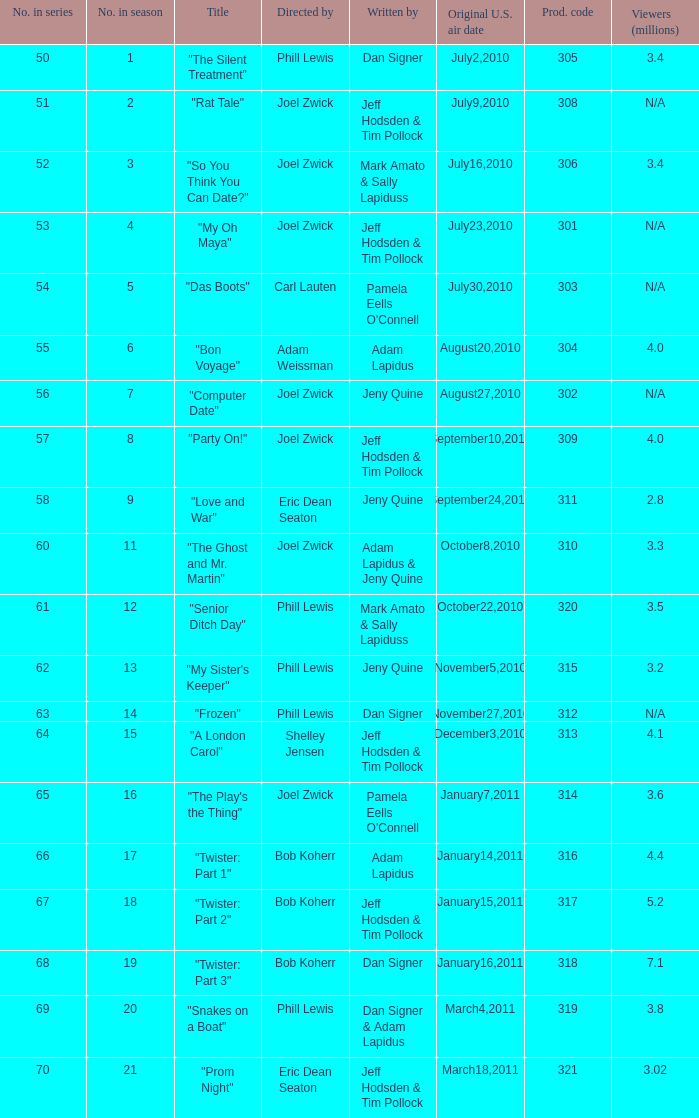Can you give me this table as a dict? {'header': ['No. in series', 'No. in season', 'Title', 'Directed by', 'Written by', 'Original U.S. air date', 'Prod. code', 'Viewers (millions)'], 'rows': [['50', '1', '"The Silent Treatment"', 'Phill Lewis', 'Dan Signer', 'July2,2010', '305', '3.4'], ['51', '2', '"Rat Tale"', 'Joel Zwick', 'Jeff Hodsden & Tim Pollock', 'July9,2010', '308', 'N/A'], ['52', '3', '"So You Think You Can Date?"', 'Joel Zwick', 'Mark Amato & Sally Lapiduss', 'July16,2010', '306', '3.4'], ['53', '4', '"My Oh Maya"', 'Joel Zwick', 'Jeff Hodsden & Tim Pollock', 'July23,2010', '301', 'N/A'], ['54', '5', '"Das Boots"', 'Carl Lauten', "Pamela Eells O'Connell", 'July30,2010', '303', 'N/A'], ['55', '6', '"Bon Voyage"', 'Adam Weissman', 'Adam Lapidus', 'August20,2010', '304', '4.0'], ['56', '7', '"Computer Date"', 'Joel Zwick', 'Jeny Quine', 'August27,2010', '302', 'N/A'], ['57', '8', '"Party On!"', 'Joel Zwick', 'Jeff Hodsden & Tim Pollock', 'September10,2010', '309', '4.0'], ['58', '9', '"Love and War"', 'Eric Dean Seaton', 'Jeny Quine', 'September24,2010', '311', '2.8'], ['60', '11', '"The Ghost and Mr. Martin"', 'Joel Zwick', 'Adam Lapidus & Jeny Quine', 'October8,2010', '310', '3.3'], ['61', '12', '"Senior Ditch Day"', 'Phill Lewis', 'Mark Amato & Sally Lapiduss', 'October22,2010', '320', '3.5'], ['62', '13', '"My Sister\'s Keeper"', 'Phill Lewis', 'Jeny Quine', 'November5,2010', '315', '3.2'], ['63', '14', '"Frozen"', 'Phill Lewis', 'Dan Signer', 'November27,2010', '312', 'N/A'], ['64', '15', '"A London Carol"', 'Shelley Jensen', 'Jeff Hodsden & Tim Pollock', 'December3,2010', '313', '4.1'], ['65', '16', '"The Play\'s the Thing"', 'Joel Zwick', "Pamela Eells O'Connell", 'January7,2011', '314', '3.6'], ['66', '17', '"Twister: Part 1"', 'Bob Koherr', 'Adam Lapidus', 'January14,2011', '316', '4.4'], ['67', '18', '"Twister: Part 2"', 'Bob Koherr', 'Jeff Hodsden & Tim Pollock', 'January15,2011', '317', '5.2'], ['68', '19', '"Twister: Part 3"', 'Bob Koherr', 'Dan Signer', 'January16,2011', '318', '7.1'], ['69', '20', '"Snakes on a Boat"', 'Phill Lewis', 'Dan Signer & Adam Lapidus', 'March4,2011', '319', '3.8'], ['70', '21', '"Prom Night"', 'Eric Dean Seaton', 'Jeff Hodsden & Tim Pollock', 'March18,2011', '321', '3.02']]} What episode number was titled "my oh maya"? 4.0. 